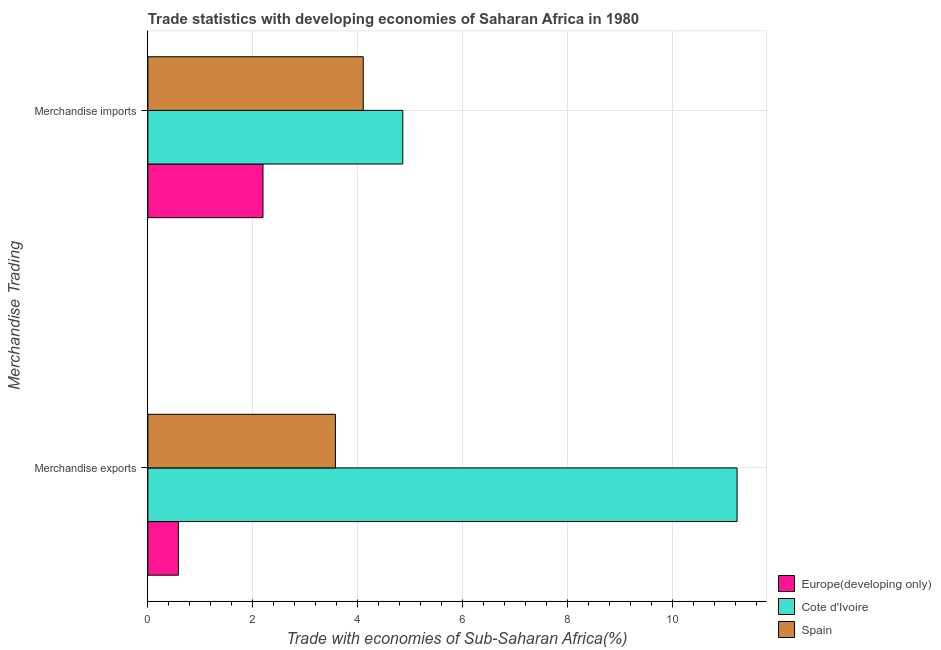How many different coloured bars are there?
Your response must be concise. 3. How many groups of bars are there?
Your response must be concise. 2. Are the number of bars per tick equal to the number of legend labels?
Your answer should be very brief. Yes. What is the merchandise exports in Spain?
Offer a terse response. 3.58. Across all countries, what is the maximum merchandise imports?
Offer a very short reply. 4.86. Across all countries, what is the minimum merchandise exports?
Provide a succinct answer. 0.58. In which country was the merchandise imports maximum?
Your answer should be compact. Cote d'Ivoire. In which country was the merchandise imports minimum?
Offer a terse response. Europe(developing only). What is the total merchandise imports in the graph?
Your response must be concise. 11.16. What is the difference between the merchandise exports in Spain and that in Cote d'Ivoire?
Your answer should be very brief. -7.66. What is the difference between the merchandise imports in Spain and the merchandise exports in Cote d'Ivoire?
Provide a succinct answer. -7.13. What is the average merchandise imports per country?
Ensure brevity in your answer.  3.72. What is the difference between the merchandise exports and merchandise imports in Europe(developing only)?
Offer a terse response. -1.61. What is the ratio of the merchandise imports in Cote d'Ivoire to that in Europe(developing only)?
Your answer should be compact. 2.21. What does the 2nd bar from the top in Merchandise exports represents?
Ensure brevity in your answer.  Cote d'Ivoire. What does the 1st bar from the bottom in Merchandise imports represents?
Ensure brevity in your answer.  Europe(developing only). What is the difference between two consecutive major ticks on the X-axis?
Offer a terse response. 2. Are the values on the major ticks of X-axis written in scientific E-notation?
Ensure brevity in your answer.  No. Does the graph contain any zero values?
Make the answer very short. No. Does the graph contain grids?
Give a very brief answer. Yes. How many legend labels are there?
Make the answer very short. 3. How are the legend labels stacked?
Provide a short and direct response. Vertical. What is the title of the graph?
Make the answer very short. Trade statistics with developing economies of Saharan Africa in 1980. Does "Djibouti" appear as one of the legend labels in the graph?
Provide a short and direct response. No. What is the label or title of the X-axis?
Offer a very short reply. Trade with economies of Sub-Saharan Africa(%). What is the label or title of the Y-axis?
Your answer should be compact. Merchandise Trading. What is the Trade with economies of Sub-Saharan Africa(%) in Europe(developing only) in Merchandise exports?
Offer a terse response. 0.58. What is the Trade with economies of Sub-Saharan Africa(%) in Cote d'Ivoire in Merchandise exports?
Provide a short and direct response. 11.23. What is the Trade with economies of Sub-Saharan Africa(%) in Spain in Merchandise exports?
Give a very brief answer. 3.58. What is the Trade with economies of Sub-Saharan Africa(%) in Europe(developing only) in Merchandise imports?
Offer a very short reply. 2.19. What is the Trade with economies of Sub-Saharan Africa(%) in Cote d'Ivoire in Merchandise imports?
Keep it short and to the point. 4.86. What is the Trade with economies of Sub-Saharan Africa(%) in Spain in Merchandise imports?
Give a very brief answer. 4.11. Across all Merchandise Trading, what is the maximum Trade with economies of Sub-Saharan Africa(%) of Europe(developing only)?
Keep it short and to the point. 2.19. Across all Merchandise Trading, what is the maximum Trade with economies of Sub-Saharan Africa(%) in Cote d'Ivoire?
Provide a short and direct response. 11.23. Across all Merchandise Trading, what is the maximum Trade with economies of Sub-Saharan Africa(%) in Spain?
Offer a terse response. 4.11. Across all Merchandise Trading, what is the minimum Trade with economies of Sub-Saharan Africa(%) in Europe(developing only)?
Provide a succinct answer. 0.58. Across all Merchandise Trading, what is the minimum Trade with economies of Sub-Saharan Africa(%) of Cote d'Ivoire?
Offer a terse response. 4.86. Across all Merchandise Trading, what is the minimum Trade with economies of Sub-Saharan Africa(%) in Spain?
Offer a very short reply. 3.58. What is the total Trade with economies of Sub-Saharan Africa(%) in Europe(developing only) in the graph?
Your answer should be compact. 2.78. What is the total Trade with economies of Sub-Saharan Africa(%) in Cote d'Ivoire in the graph?
Provide a short and direct response. 16.09. What is the total Trade with economies of Sub-Saharan Africa(%) of Spain in the graph?
Keep it short and to the point. 7.68. What is the difference between the Trade with economies of Sub-Saharan Africa(%) in Europe(developing only) in Merchandise exports and that in Merchandise imports?
Your response must be concise. -1.61. What is the difference between the Trade with economies of Sub-Saharan Africa(%) in Cote d'Ivoire in Merchandise exports and that in Merchandise imports?
Ensure brevity in your answer.  6.37. What is the difference between the Trade with economies of Sub-Saharan Africa(%) in Spain in Merchandise exports and that in Merchandise imports?
Offer a terse response. -0.53. What is the difference between the Trade with economies of Sub-Saharan Africa(%) of Europe(developing only) in Merchandise exports and the Trade with economies of Sub-Saharan Africa(%) of Cote d'Ivoire in Merchandise imports?
Ensure brevity in your answer.  -4.28. What is the difference between the Trade with economies of Sub-Saharan Africa(%) of Europe(developing only) in Merchandise exports and the Trade with economies of Sub-Saharan Africa(%) of Spain in Merchandise imports?
Give a very brief answer. -3.52. What is the difference between the Trade with economies of Sub-Saharan Africa(%) of Cote d'Ivoire in Merchandise exports and the Trade with economies of Sub-Saharan Africa(%) of Spain in Merchandise imports?
Your answer should be compact. 7.13. What is the average Trade with economies of Sub-Saharan Africa(%) of Europe(developing only) per Merchandise Trading?
Give a very brief answer. 1.39. What is the average Trade with economies of Sub-Saharan Africa(%) of Cote d'Ivoire per Merchandise Trading?
Make the answer very short. 8.05. What is the average Trade with economies of Sub-Saharan Africa(%) of Spain per Merchandise Trading?
Offer a very short reply. 3.84. What is the difference between the Trade with economies of Sub-Saharan Africa(%) of Europe(developing only) and Trade with economies of Sub-Saharan Africa(%) of Cote d'Ivoire in Merchandise exports?
Offer a very short reply. -10.65. What is the difference between the Trade with economies of Sub-Saharan Africa(%) in Europe(developing only) and Trade with economies of Sub-Saharan Africa(%) in Spain in Merchandise exports?
Make the answer very short. -2.99. What is the difference between the Trade with economies of Sub-Saharan Africa(%) in Cote d'Ivoire and Trade with economies of Sub-Saharan Africa(%) in Spain in Merchandise exports?
Give a very brief answer. 7.66. What is the difference between the Trade with economies of Sub-Saharan Africa(%) of Europe(developing only) and Trade with economies of Sub-Saharan Africa(%) of Cote d'Ivoire in Merchandise imports?
Make the answer very short. -2.67. What is the difference between the Trade with economies of Sub-Saharan Africa(%) in Europe(developing only) and Trade with economies of Sub-Saharan Africa(%) in Spain in Merchandise imports?
Your response must be concise. -1.91. What is the difference between the Trade with economies of Sub-Saharan Africa(%) of Cote d'Ivoire and Trade with economies of Sub-Saharan Africa(%) of Spain in Merchandise imports?
Keep it short and to the point. 0.75. What is the ratio of the Trade with economies of Sub-Saharan Africa(%) in Europe(developing only) in Merchandise exports to that in Merchandise imports?
Your answer should be compact. 0.27. What is the ratio of the Trade with economies of Sub-Saharan Africa(%) of Cote d'Ivoire in Merchandise exports to that in Merchandise imports?
Provide a short and direct response. 2.31. What is the ratio of the Trade with economies of Sub-Saharan Africa(%) of Spain in Merchandise exports to that in Merchandise imports?
Your answer should be compact. 0.87. What is the difference between the highest and the second highest Trade with economies of Sub-Saharan Africa(%) in Europe(developing only)?
Give a very brief answer. 1.61. What is the difference between the highest and the second highest Trade with economies of Sub-Saharan Africa(%) in Cote d'Ivoire?
Make the answer very short. 6.37. What is the difference between the highest and the second highest Trade with economies of Sub-Saharan Africa(%) of Spain?
Provide a succinct answer. 0.53. What is the difference between the highest and the lowest Trade with economies of Sub-Saharan Africa(%) in Europe(developing only)?
Offer a terse response. 1.61. What is the difference between the highest and the lowest Trade with economies of Sub-Saharan Africa(%) in Cote d'Ivoire?
Provide a succinct answer. 6.37. What is the difference between the highest and the lowest Trade with economies of Sub-Saharan Africa(%) of Spain?
Offer a very short reply. 0.53. 